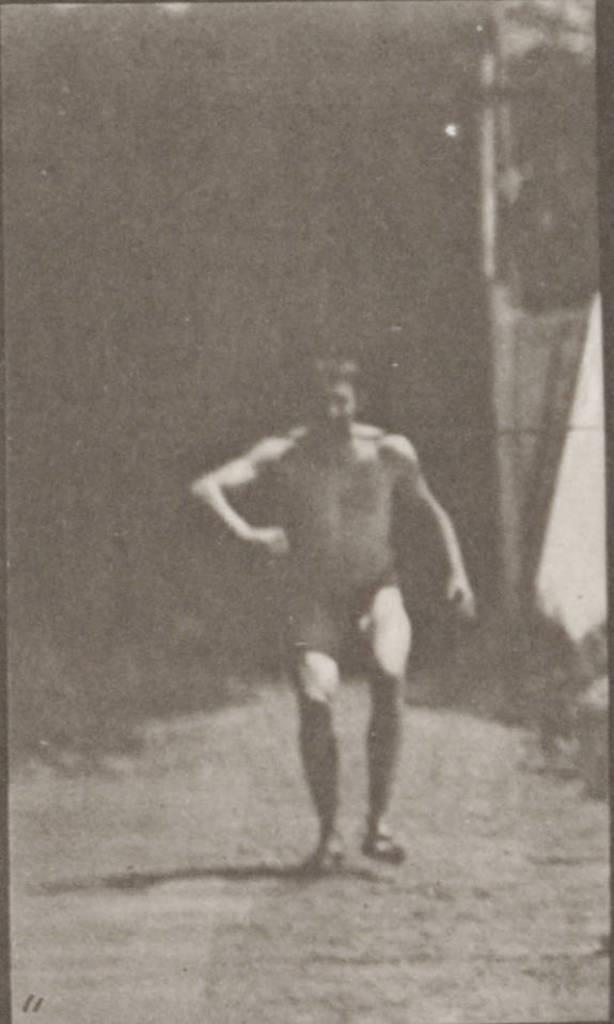Describe this image in one or two sentences. This is a black and white image, in the image there is a person, behind the person there is a wall. 